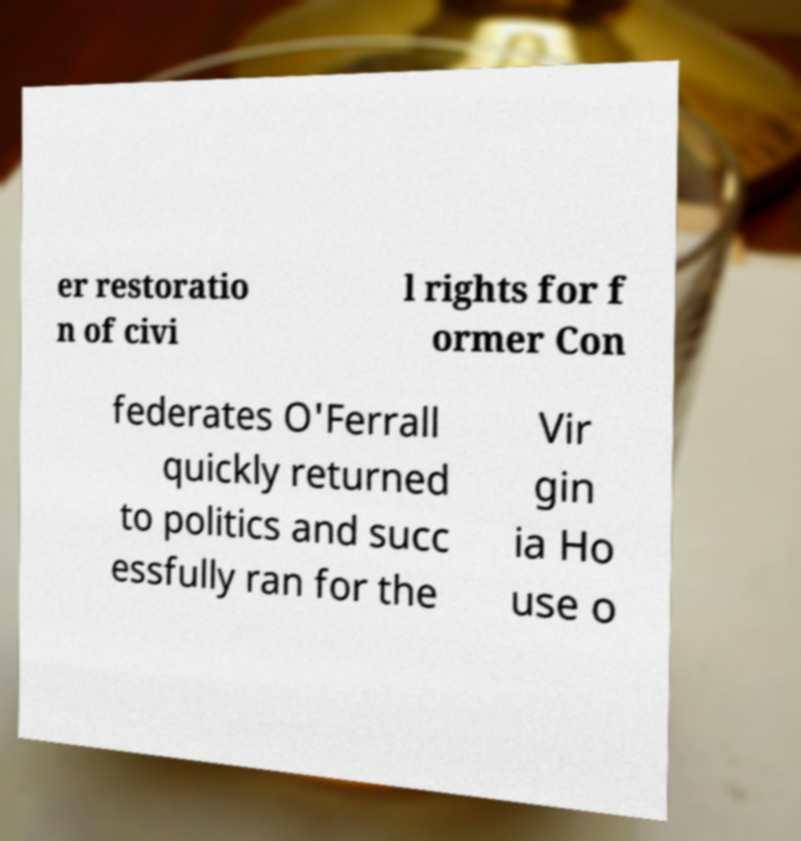Please identify and transcribe the text found in this image. er restoratio n of civi l rights for f ormer Con federates O'Ferrall quickly returned to politics and succ essfully ran for the Vir gin ia Ho use o 